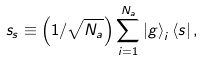<formula> <loc_0><loc_0><loc_500><loc_500>s _ { s } \equiv \left ( 1 / \sqrt { N _ { a } } \right ) \sum _ { i = 1 } ^ { N _ { a } } \left | g \right \rangle _ { i } \left \langle s \right | ,</formula> 